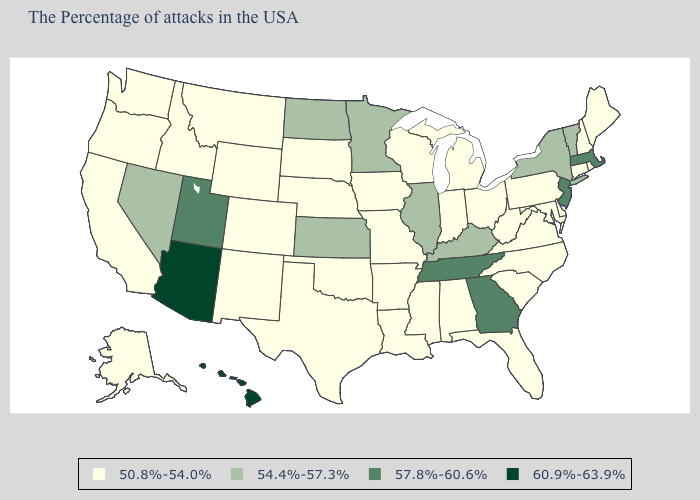Among the states that border South Carolina , does North Carolina have the highest value?
Give a very brief answer. No. Name the states that have a value in the range 50.8%-54.0%?
Be succinct. Maine, Rhode Island, New Hampshire, Connecticut, Delaware, Maryland, Pennsylvania, Virginia, North Carolina, South Carolina, West Virginia, Ohio, Florida, Michigan, Indiana, Alabama, Wisconsin, Mississippi, Louisiana, Missouri, Arkansas, Iowa, Nebraska, Oklahoma, Texas, South Dakota, Wyoming, Colorado, New Mexico, Montana, Idaho, California, Washington, Oregon, Alaska. Is the legend a continuous bar?
Give a very brief answer. No. Name the states that have a value in the range 57.8%-60.6%?
Concise answer only. Massachusetts, New Jersey, Georgia, Tennessee, Utah. Does Tennessee have the lowest value in the South?
Give a very brief answer. No. Does Utah have the lowest value in the West?
Write a very short answer. No. Name the states that have a value in the range 54.4%-57.3%?
Be succinct. Vermont, New York, Kentucky, Illinois, Minnesota, Kansas, North Dakota, Nevada. How many symbols are there in the legend?
Short answer required. 4. Name the states that have a value in the range 60.9%-63.9%?
Answer briefly. Arizona, Hawaii. Which states hav the highest value in the West?
Keep it brief. Arizona, Hawaii. Name the states that have a value in the range 60.9%-63.9%?
Give a very brief answer. Arizona, Hawaii. Among the states that border Rhode Island , does Massachusetts have the lowest value?
Give a very brief answer. No. What is the value of North Carolina?
Concise answer only. 50.8%-54.0%. Among the states that border New Jersey , which have the lowest value?
Short answer required. Delaware, Pennsylvania. Does the map have missing data?
Be succinct. No. 